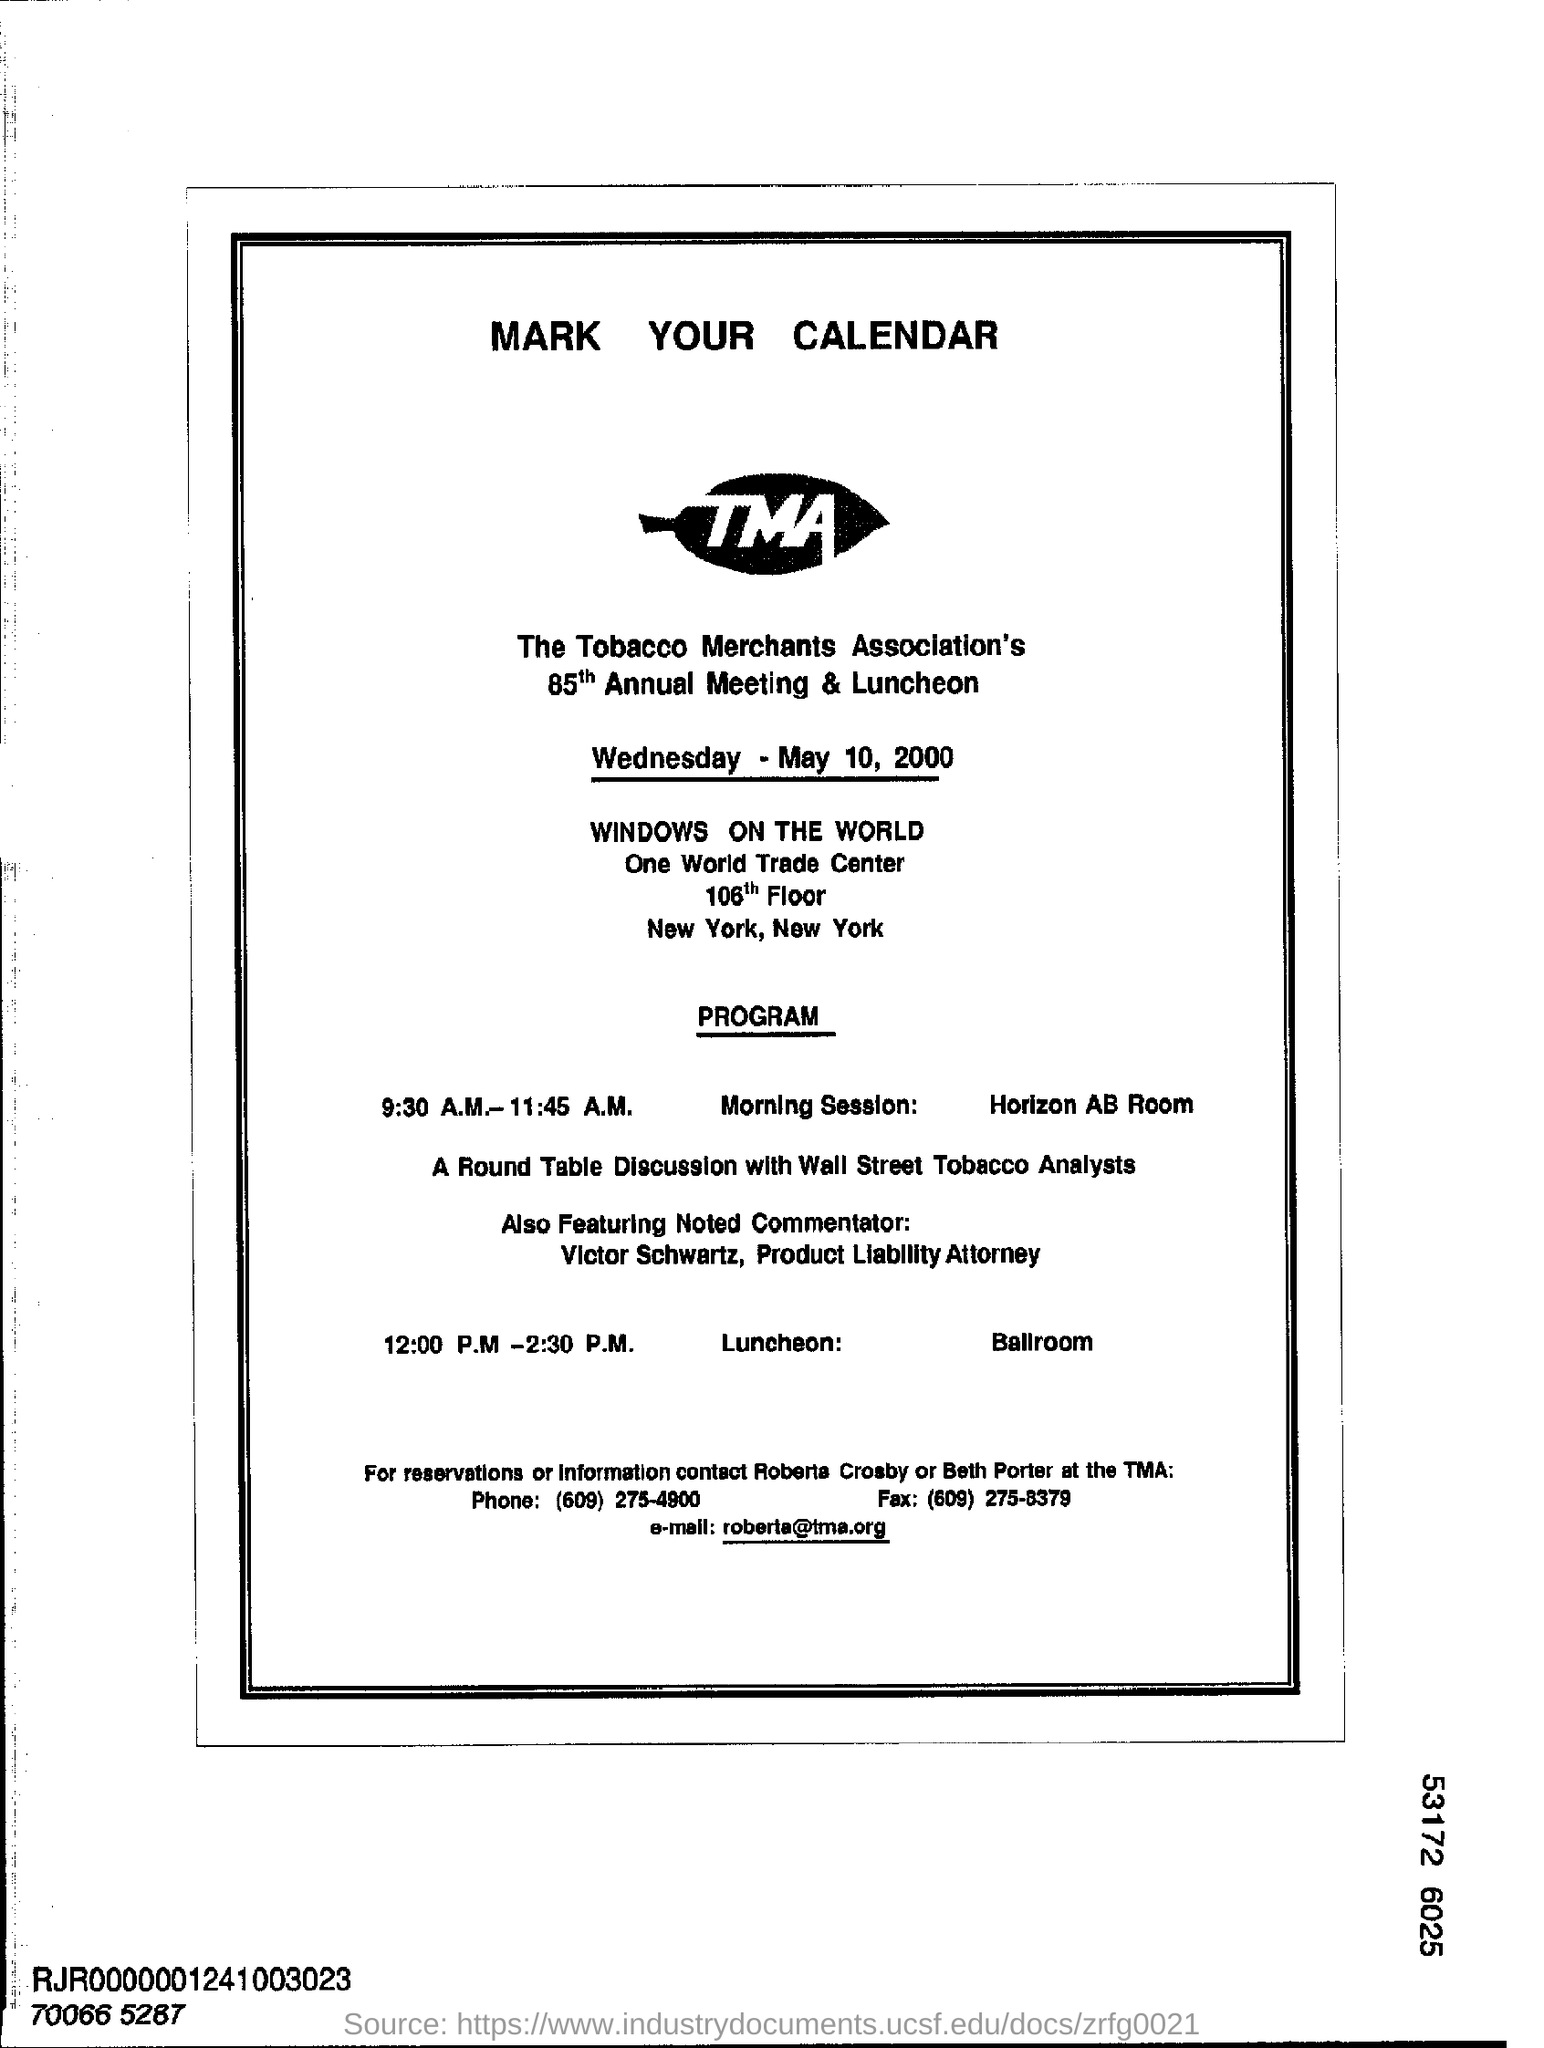Specify some key components in this picture. The morning session of the 85th annual meeting was conducted in the Horizon AB Room. The phone number is (609) 275-4900. The Tobacco Merchants Association is hosting the 85th annual meeting and Luncheon in New York. The email address mentioned at the bottom of the notice is "[roberta@tma.org](mailto:roberta@tma.org)". On Wednesday, May 10th, 2000, the 85th Annual Meeting was conducted. 